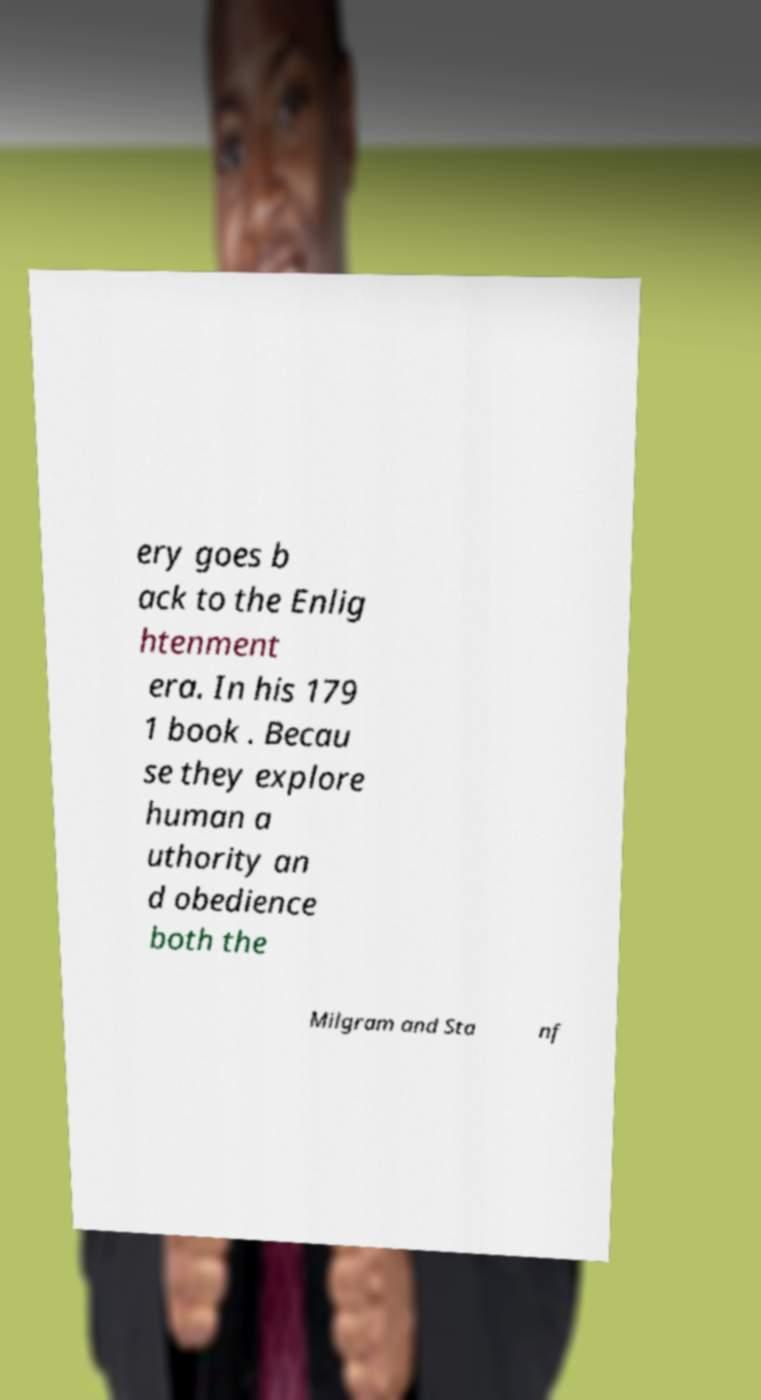Could you extract and type out the text from this image? ery goes b ack to the Enlig htenment era. In his 179 1 book . Becau se they explore human a uthority an d obedience both the Milgram and Sta nf 